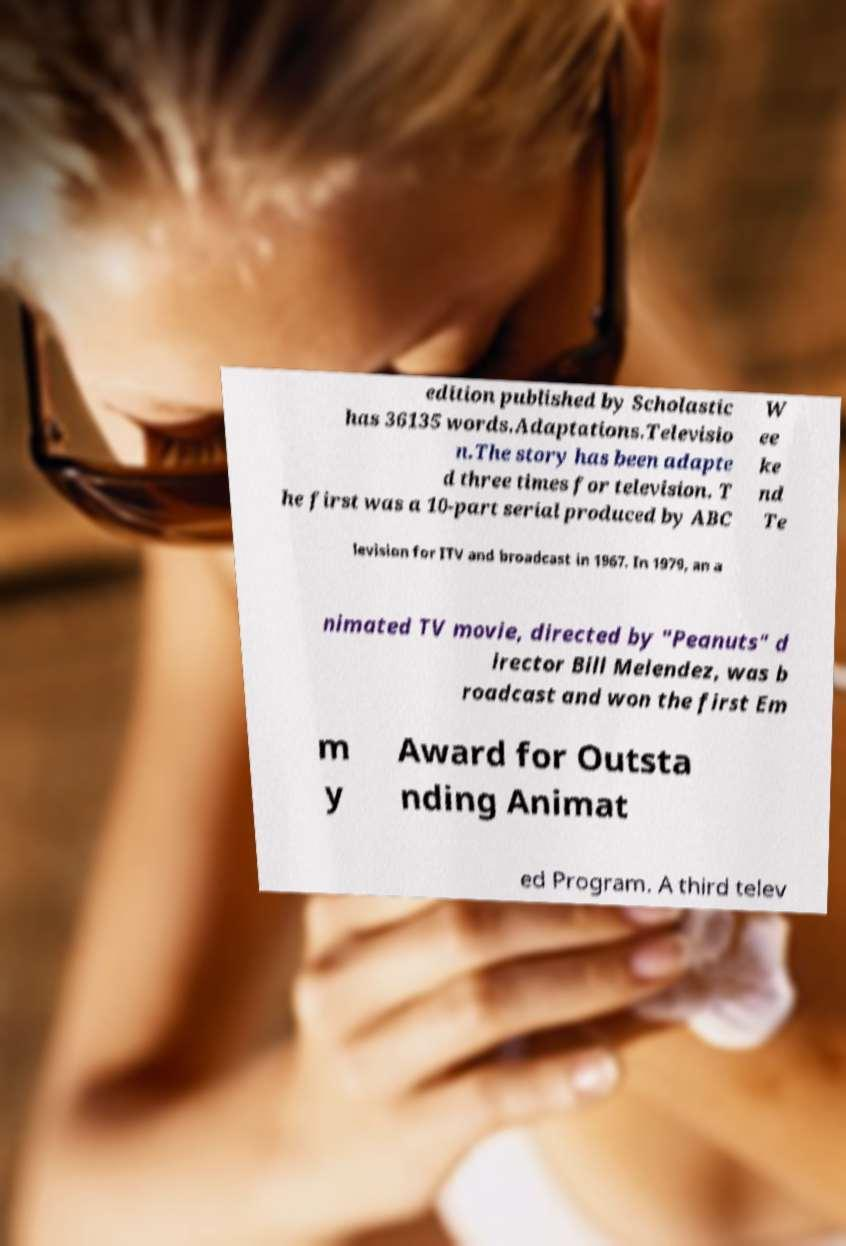There's text embedded in this image that I need extracted. Can you transcribe it verbatim? edition published by Scholastic has 36135 words.Adaptations.Televisio n.The story has been adapte d three times for television. T he first was a 10-part serial produced by ABC W ee ke nd Te levision for ITV and broadcast in 1967. In 1979, an a nimated TV movie, directed by "Peanuts" d irector Bill Melendez, was b roadcast and won the first Em m y Award for Outsta nding Animat ed Program. A third telev 